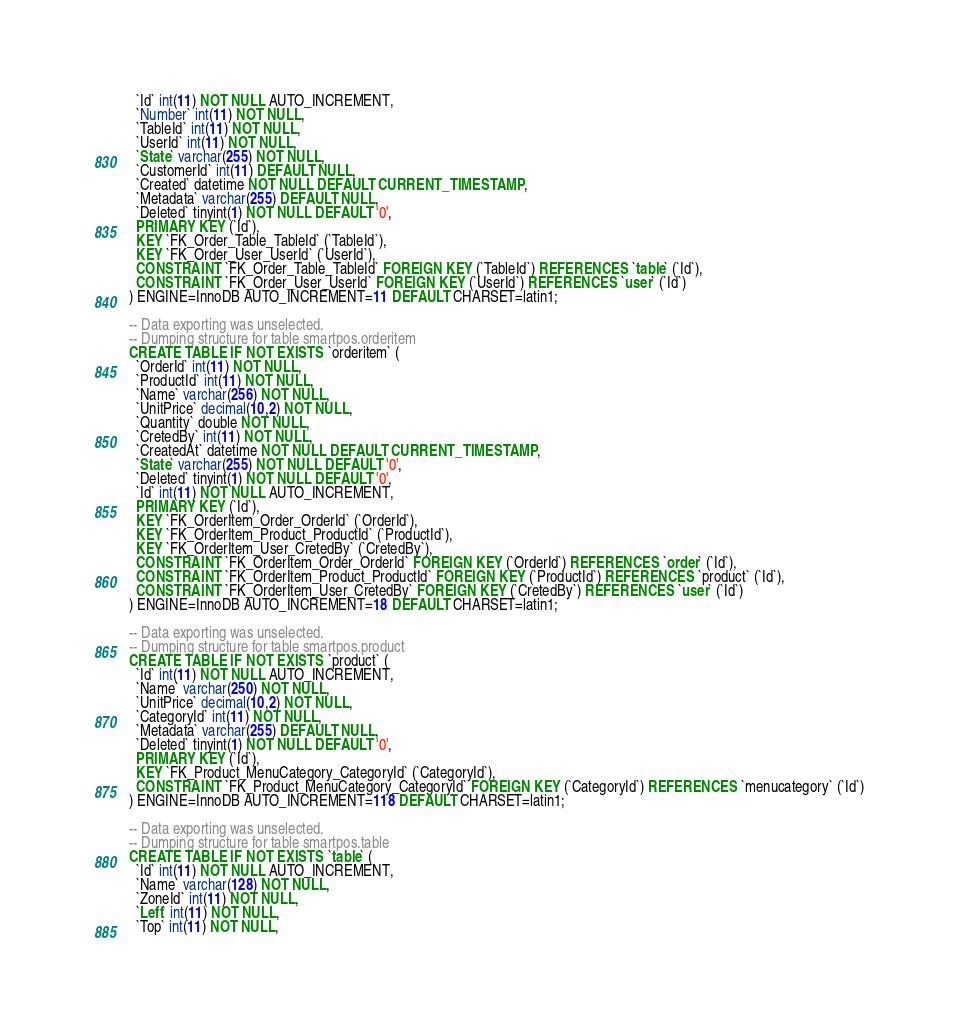<code> <loc_0><loc_0><loc_500><loc_500><_SQL_>  `Id` int(11) NOT NULL AUTO_INCREMENT,
  `Number` int(11) NOT NULL,
  `TableId` int(11) NOT NULL,
  `UserId` int(11) NOT NULL,
  `State` varchar(255) NOT NULL,
  `CustomerId` int(11) DEFAULT NULL,
  `Created` datetime NOT NULL DEFAULT CURRENT_TIMESTAMP,
  `Metadata` varchar(255) DEFAULT NULL,
  `Deleted` tinyint(1) NOT NULL DEFAULT '0',
  PRIMARY KEY (`Id`),
  KEY `FK_Order_Table_TableId` (`TableId`),
  KEY `FK_Order_User_UserId` (`UserId`),
  CONSTRAINT `FK_Order_Table_TableId` FOREIGN KEY (`TableId`) REFERENCES `table` (`Id`),
  CONSTRAINT `FK_Order_User_UserId` FOREIGN KEY (`UserId`) REFERENCES `user` (`Id`)
) ENGINE=InnoDB AUTO_INCREMENT=11 DEFAULT CHARSET=latin1;

-- Data exporting was unselected.
-- Dumping structure for table smartpos.orderitem
CREATE TABLE IF NOT EXISTS `orderitem` (
  `OrderId` int(11) NOT NULL,
  `ProductId` int(11) NOT NULL,
  `Name` varchar(256) NOT NULL,
  `UnitPrice` decimal(10,2) NOT NULL,
  `Quantity` double NOT NULL,
  `CretedBy` int(11) NOT NULL,
  `CreatedAt` datetime NOT NULL DEFAULT CURRENT_TIMESTAMP,
  `State` varchar(255) NOT NULL DEFAULT '0',
  `Deleted` tinyint(1) NOT NULL DEFAULT '0',
  `Id` int(11) NOT NULL AUTO_INCREMENT,
  PRIMARY KEY (`Id`),
  KEY `FK_OrderItem_Order_OrderId` (`OrderId`),
  KEY `FK_OrderItem_Product_ProductId` (`ProductId`),
  KEY `FK_OrderItem_User_CretedBy` (`CretedBy`),
  CONSTRAINT `FK_OrderItem_Order_OrderId` FOREIGN KEY (`OrderId`) REFERENCES `order` (`Id`),
  CONSTRAINT `FK_OrderItem_Product_ProductId` FOREIGN KEY (`ProductId`) REFERENCES `product` (`Id`),
  CONSTRAINT `FK_OrderItem_User_CretedBy` FOREIGN KEY (`CretedBy`) REFERENCES `user` (`Id`)
) ENGINE=InnoDB AUTO_INCREMENT=18 DEFAULT CHARSET=latin1;

-- Data exporting was unselected.
-- Dumping structure for table smartpos.product
CREATE TABLE IF NOT EXISTS `product` (
  `Id` int(11) NOT NULL AUTO_INCREMENT,
  `Name` varchar(250) NOT NULL,
  `UnitPrice` decimal(10,2) NOT NULL,
  `CategoryId` int(11) NOT NULL,
  `Metadata` varchar(255) DEFAULT NULL,
  `Deleted` tinyint(1) NOT NULL DEFAULT '0',
  PRIMARY KEY (`Id`),
  KEY `FK_Product_MenuCategory_CategoryId` (`CategoryId`),
  CONSTRAINT `FK_Product_MenuCategory_CategoryId` FOREIGN KEY (`CategoryId`) REFERENCES `menucategory` (`Id`)
) ENGINE=InnoDB AUTO_INCREMENT=118 DEFAULT CHARSET=latin1;

-- Data exporting was unselected.
-- Dumping structure for table smartpos.table
CREATE TABLE IF NOT EXISTS `table` (
  `Id` int(11) NOT NULL AUTO_INCREMENT,
  `Name` varchar(128) NOT NULL,
  `ZoneId` int(11) NOT NULL,
  `Left` int(11) NOT NULL,
  `Top` int(11) NOT NULL,</code> 